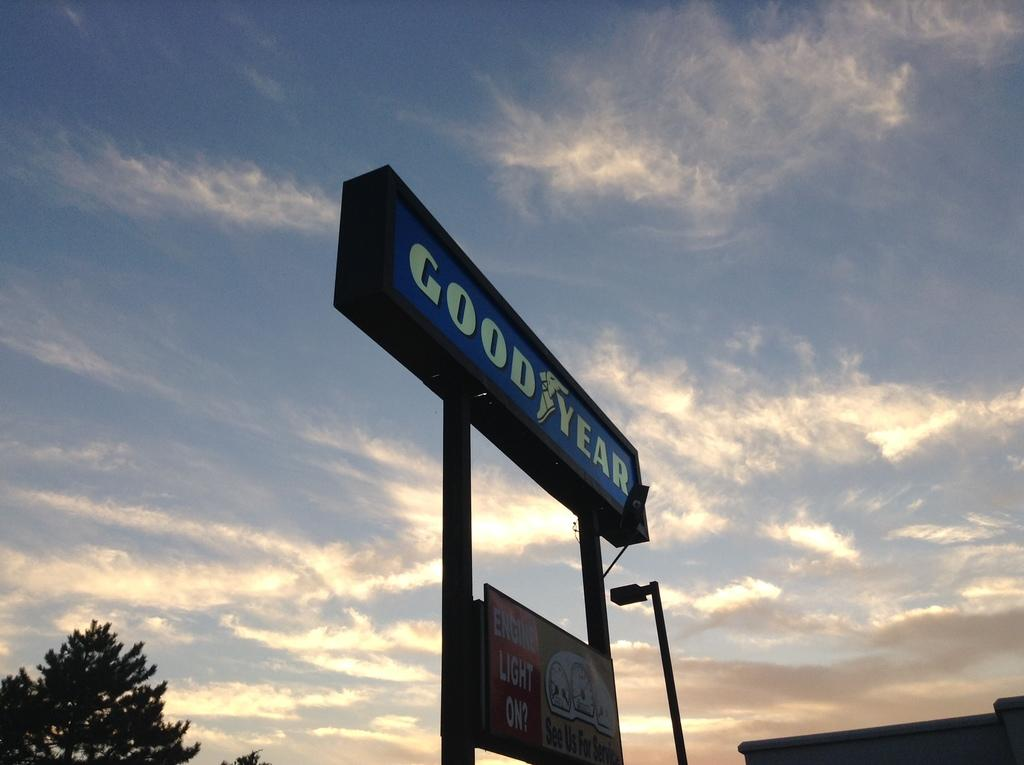<image>
Share a concise interpretation of the image provided. A large sign advertising Good year is shown in the blue sky background 